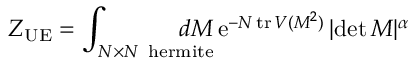Convert formula to latex. <formula><loc_0><loc_0><loc_500><loc_500>Z _ { U E } = \int _ { N \times N \, h e r m i t e } \, d M \, e ^ { - N \, t r \, V ( M ^ { 2 } ) } \, | d e t \, M | ^ { \alpha }</formula> 